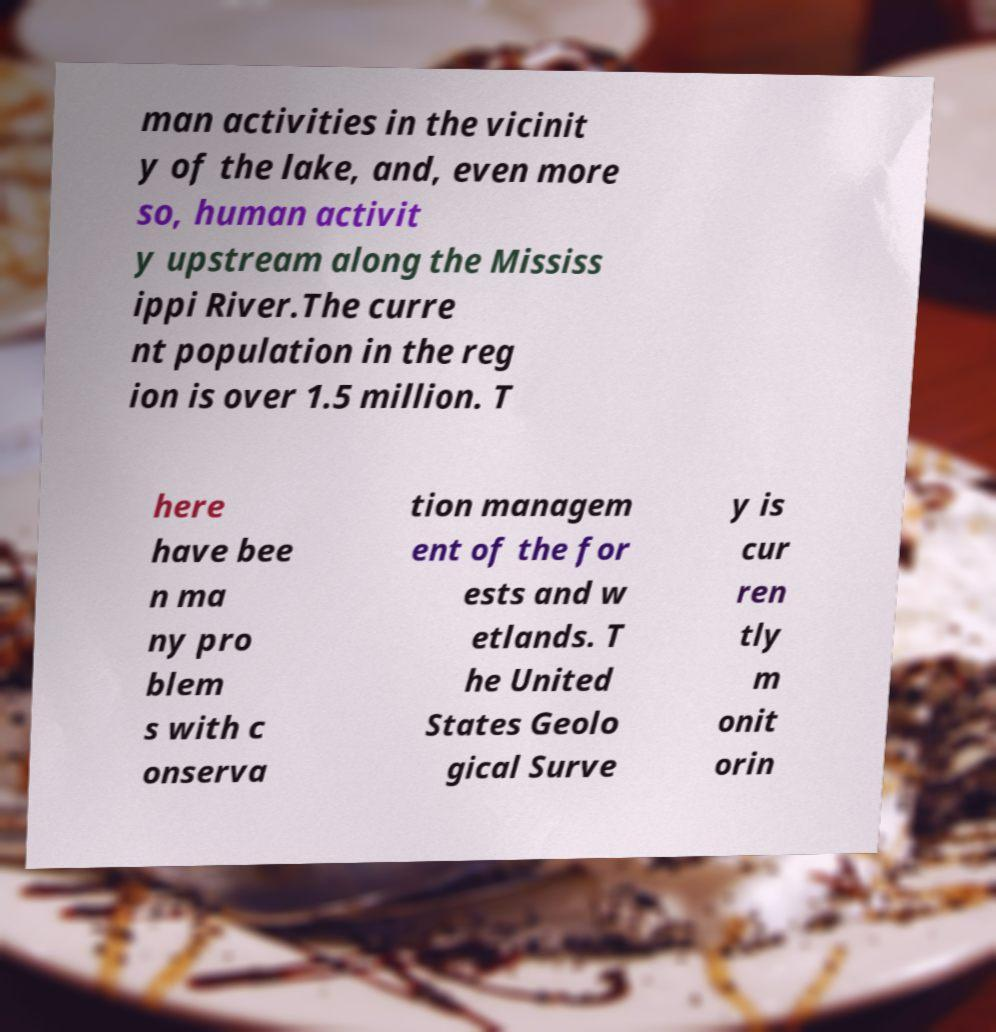Can you read and provide the text displayed in the image?This photo seems to have some interesting text. Can you extract and type it out for me? man activities in the vicinit y of the lake, and, even more so, human activit y upstream along the Mississ ippi River.The curre nt population in the reg ion is over 1.5 million. T here have bee n ma ny pro blem s with c onserva tion managem ent of the for ests and w etlands. T he United States Geolo gical Surve y is cur ren tly m onit orin 